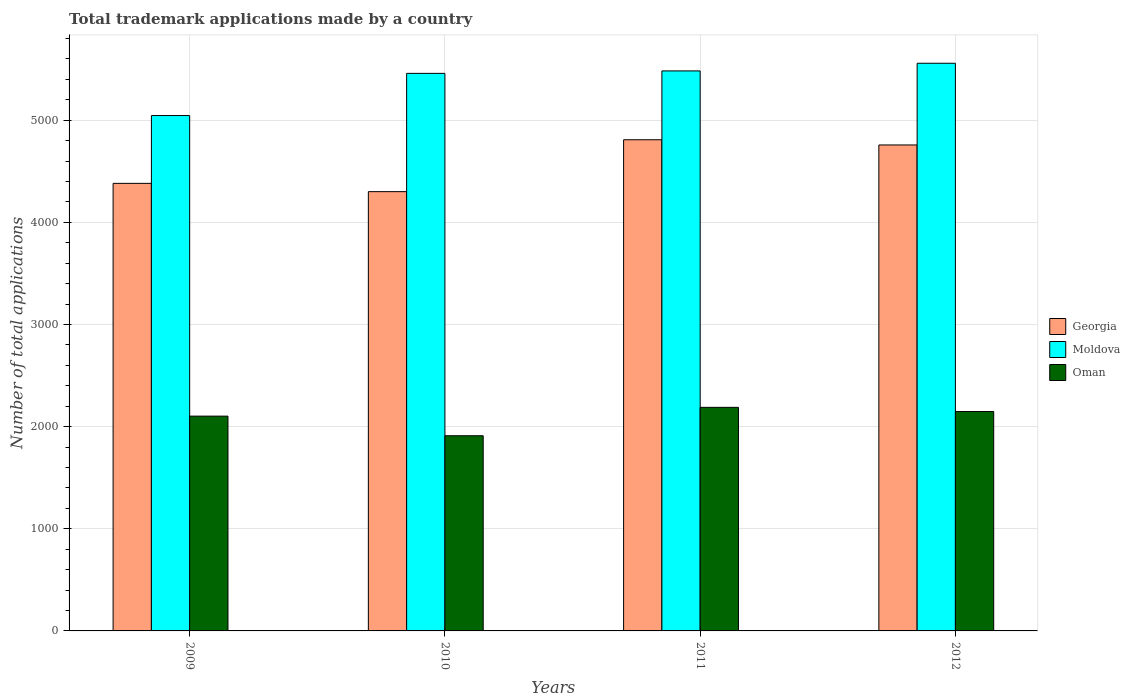How many different coloured bars are there?
Give a very brief answer. 3. Are the number of bars per tick equal to the number of legend labels?
Make the answer very short. Yes. How many bars are there on the 3rd tick from the right?
Offer a terse response. 3. What is the number of applications made by in Moldova in 2011?
Provide a short and direct response. 5483. Across all years, what is the maximum number of applications made by in Moldova?
Offer a very short reply. 5558. Across all years, what is the minimum number of applications made by in Moldova?
Your response must be concise. 5046. In which year was the number of applications made by in Moldova maximum?
Your response must be concise. 2012. In which year was the number of applications made by in Georgia minimum?
Offer a terse response. 2010. What is the total number of applications made by in Georgia in the graph?
Make the answer very short. 1.82e+04. What is the difference between the number of applications made by in Moldova in 2009 and that in 2011?
Keep it short and to the point. -437. What is the difference between the number of applications made by in Georgia in 2011 and the number of applications made by in Oman in 2009?
Offer a terse response. 2706. What is the average number of applications made by in Oman per year?
Provide a succinct answer. 2087.75. In the year 2012, what is the difference between the number of applications made by in Oman and number of applications made by in Moldova?
Keep it short and to the point. -3410. What is the ratio of the number of applications made by in Oman in 2010 to that in 2012?
Offer a very short reply. 0.89. Is the difference between the number of applications made by in Oman in 2009 and 2010 greater than the difference between the number of applications made by in Moldova in 2009 and 2010?
Keep it short and to the point. Yes. What is the difference between the highest and the second highest number of applications made by in Moldova?
Make the answer very short. 75. What is the difference between the highest and the lowest number of applications made by in Oman?
Offer a terse response. 278. In how many years, is the number of applications made by in Oman greater than the average number of applications made by in Oman taken over all years?
Give a very brief answer. 3. Is the sum of the number of applications made by in Moldova in 2009 and 2011 greater than the maximum number of applications made by in Georgia across all years?
Make the answer very short. Yes. What does the 1st bar from the left in 2012 represents?
Your response must be concise. Georgia. What does the 1st bar from the right in 2011 represents?
Provide a succinct answer. Oman. Is it the case that in every year, the sum of the number of applications made by in Moldova and number of applications made by in Oman is greater than the number of applications made by in Georgia?
Make the answer very short. Yes. Are all the bars in the graph horizontal?
Provide a succinct answer. No. Are the values on the major ticks of Y-axis written in scientific E-notation?
Your answer should be very brief. No. How are the legend labels stacked?
Your answer should be very brief. Vertical. What is the title of the graph?
Offer a very short reply. Total trademark applications made by a country. What is the label or title of the Y-axis?
Your answer should be compact. Number of total applications. What is the Number of total applications in Georgia in 2009?
Your response must be concise. 4382. What is the Number of total applications in Moldova in 2009?
Make the answer very short. 5046. What is the Number of total applications in Oman in 2009?
Offer a terse response. 2103. What is the Number of total applications of Georgia in 2010?
Your answer should be compact. 4301. What is the Number of total applications of Moldova in 2010?
Offer a very short reply. 5459. What is the Number of total applications of Oman in 2010?
Make the answer very short. 1911. What is the Number of total applications of Georgia in 2011?
Make the answer very short. 4809. What is the Number of total applications of Moldova in 2011?
Your answer should be very brief. 5483. What is the Number of total applications in Oman in 2011?
Your answer should be very brief. 2189. What is the Number of total applications in Georgia in 2012?
Offer a terse response. 4758. What is the Number of total applications of Moldova in 2012?
Keep it short and to the point. 5558. What is the Number of total applications in Oman in 2012?
Your response must be concise. 2148. Across all years, what is the maximum Number of total applications in Georgia?
Provide a short and direct response. 4809. Across all years, what is the maximum Number of total applications of Moldova?
Offer a very short reply. 5558. Across all years, what is the maximum Number of total applications of Oman?
Offer a terse response. 2189. Across all years, what is the minimum Number of total applications in Georgia?
Your response must be concise. 4301. Across all years, what is the minimum Number of total applications in Moldova?
Give a very brief answer. 5046. Across all years, what is the minimum Number of total applications of Oman?
Provide a succinct answer. 1911. What is the total Number of total applications in Georgia in the graph?
Provide a succinct answer. 1.82e+04. What is the total Number of total applications of Moldova in the graph?
Provide a short and direct response. 2.15e+04. What is the total Number of total applications in Oman in the graph?
Give a very brief answer. 8351. What is the difference between the Number of total applications in Georgia in 2009 and that in 2010?
Your answer should be compact. 81. What is the difference between the Number of total applications in Moldova in 2009 and that in 2010?
Offer a terse response. -413. What is the difference between the Number of total applications of Oman in 2009 and that in 2010?
Your response must be concise. 192. What is the difference between the Number of total applications of Georgia in 2009 and that in 2011?
Make the answer very short. -427. What is the difference between the Number of total applications in Moldova in 2009 and that in 2011?
Keep it short and to the point. -437. What is the difference between the Number of total applications in Oman in 2009 and that in 2011?
Your response must be concise. -86. What is the difference between the Number of total applications in Georgia in 2009 and that in 2012?
Your answer should be very brief. -376. What is the difference between the Number of total applications in Moldova in 2009 and that in 2012?
Keep it short and to the point. -512. What is the difference between the Number of total applications of Oman in 2009 and that in 2012?
Your answer should be compact. -45. What is the difference between the Number of total applications in Georgia in 2010 and that in 2011?
Your response must be concise. -508. What is the difference between the Number of total applications of Oman in 2010 and that in 2011?
Your answer should be compact. -278. What is the difference between the Number of total applications in Georgia in 2010 and that in 2012?
Give a very brief answer. -457. What is the difference between the Number of total applications of Moldova in 2010 and that in 2012?
Your response must be concise. -99. What is the difference between the Number of total applications of Oman in 2010 and that in 2012?
Offer a terse response. -237. What is the difference between the Number of total applications of Georgia in 2011 and that in 2012?
Your response must be concise. 51. What is the difference between the Number of total applications of Moldova in 2011 and that in 2012?
Keep it short and to the point. -75. What is the difference between the Number of total applications in Georgia in 2009 and the Number of total applications in Moldova in 2010?
Offer a terse response. -1077. What is the difference between the Number of total applications of Georgia in 2009 and the Number of total applications of Oman in 2010?
Keep it short and to the point. 2471. What is the difference between the Number of total applications of Moldova in 2009 and the Number of total applications of Oman in 2010?
Ensure brevity in your answer.  3135. What is the difference between the Number of total applications of Georgia in 2009 and the Number of total applications of Moldova in 2011?
Offer a very short reply. -1101. What is the difference between the Number of total applications of Georgia in 2009 and the Number of total applications of Oman in 2011?
Provide a succinct answer. 2193. What is the difference between the Number of total applications of Moldova in 2009 and the Number of total applications of Oman in 2011?
Keep it short and to the point. 2857. What is the difference between the Number of total applications in Georgia in 2009 and the Number of total applications in Moldova in 2012?
Keep it short and to the point. -1176. What is the difference between the Number of total applications of Georgia in 2009 and the Number of total applications of Oman in 2012?
Keep it short and to the point. 2234. What is the difference between the Number of total applications in Moldova in 2009 and the Number of total applications in Oman in 2012?
Your response must be concise. 2898. What is the difference between the Number of total applications of Georgia in 2010 and the Number of total applications of Moldova in 2011?
Your answer should be compact. -1182. What is the difference between the Number of total applications in Georgia in 2010 and the Number of total applications in Oman in 2011?
Offer a very short reply. 2112. What is the difference between the Number of total applications in Moldova in 2010 and the Number of total applications in Oman in 2011?
Ensure brevity in your answer.  3270. What is the difference between the Number of total applications in Georgia in 2010 and the Number of total applications in Moldova in 2012?
Your answer should be compact. -1257. What is the difference between the Number of total applications of Georgia in 2010 and the Number of total applications of Oman in 2012?
Offer a terse response. 2153. What is the difference between the Number of total applications of Moldova in 2010 and the Number of total applications of Oman in 2012?
Ensure brevity in your answer.  3311. What is the difference between the Number of total applications of Georgia in 2011 and the Number of total applications of Moldova in 2012?
Offer a very short reply. -749. What is the difference between the Number of total applications in Georgia in 2011 and the Number of total applications in Oman in 2012?
Your answer should be very brief. 2661. What is the difference between the Number of total applications of Moldova in 2011 and the Number of total applications of Oman in 2012?
Your response must be concise. 3335. What is the average Number of total applications of Georgia per year?
Your answer should be compact. 4562.5. What is the average Number of total applications of Moldova per year?
Offer a terse response. 5386.5. What is the average Number of total applications in Oman per year?
Your answer should be very brief. 2087.75. In the year 2009, what is the difference between the Number of total applications of Georgia and Number of total applications of Moldova?
Your answer should be compact. -664. In the year 2009, what is the difference between the Number of total applications in Georgia and Number of total applications in Oman?
Give a very brief answer. 2279. In the year 2009, what is the difference between the Number of total applications in Moldova and Number of total applications in Oman?
Provide a succinct answer. 2943. In the year 2010, what is the difference between the Number of total applications of Georgia and Number of total applications of Moldova?
Make the answer very short. -1158. In the year 2010, what is the difference between the Number of total applications of Georgia and Number of total applications of Oman?
Offer a terse response. 2390. In the year 2010, what is the difference between the Number of total applications in Moldova and Number of total applications in Oman?
Provide a succinct answer. 3548. In the year 2011, what is the difference between the Number of total applications of Georgia and Number of total applications of Moldova?
Provide a succinct answer. -674. In the year 2011, what is the difference between the Number of total applications of Georgia and Number of total applications of Oman?
Offer a very short reply. 2620. In the year 2011, what is the difference between the Number of total applications of Moldova and Number of total applications of Oman?
Give a very brief answer. 3294. In the year 2012, what is the difference between the Number of total applications of Georgia and Number of total applications of Moldova?
Your response must be concise. -800. In the year 2012, what is the difference between the Number of total applications in Georgia and Number of total applications in Oman?
Make the answer very short. 2610. In the year 2012, what is the difference between the Number of total applications in Moldova and Number of total applications in Oman?
Your answer should be very brief. 3410. What is the ratio of the Number of total applications in Georgia in 2009 to that in 2010?
Make the answer very short. 1.02. What is the ratio of the Number of total applications in Moldova in 2009 to that in 2010?
Make the answer very short. 0.92. What is the ratio of the Number of total applications in Oman in 2009 to that in 2010?
Provide a short and direct response. 1.1. What is the ratio of the Number of total applications in Georgia in 2009 to that in 2011?
Give a very brief answer. 0.91. What is the ratio of the Number of total applications of Moldova in 2009 to that in 2011?
Your response must be concise. 0.92. What is the ratio of the Number of total applications in Oman in 2009 to that in 2011?
Your response must be concise. 0.96. What is the ratio of the Number of total applications in Georgia in 2009 to that in 2012?
Provide a succinct answer. 0.92. What is the ratio of the Number of total applications in Moldova in 2009 to that in 2012?
Your answer should be very brief. 0.91. What is the ratio of the Number of total applications in Oman in 2009 to that in 2012?
Give a very brief answer. 0.98. What is the ratio of the Number of total applications of Georgia in 2010 to that in 2011?
Your response must be concise. 0.89. What is the ratio of the Number of total applications of Oman in 2010 to that in 2011?
Offer a very short reply. 0.87. What is the ratio of the Number of total applications of Georgia in 2010 to that in 2012?
Your answer should be very brief. 0.9. What is the ratio of the Number of total applications in Moldova in 2010 to that in 2012?
Offer a very short reply. 0.98. What is the ratio of the Number of total applications in Oman in 2010 to that in 2012?
Keep it short and to the point. 0.89. What is the ratio of the Number of total applications in Georgia in 2011 to that in 2012?
Offer a very short reply. 1.01. What is the ratio of the Number of total applications in Moldova in 2011 to that in 2012?
Your response must be concise. 0.99. What is the ratio of the Number of total applications in Oman in 2011 to that in 2012?
Your answer should be compact. 1.02. What is the difference between the highest and the second highest Number of total applications of Georgia?
Your response must be concise. 51. What is the difference between the highest and the second highest Number of total applications of Moldova?
Keep it short and to the point. 75. What is the difference between the highest and the lowest Number of total applications in Georgia?
Provide a short and direct response. 508. What is the difference between the highest and the lowest Number of total applications in Moldova?
Offer a terse response. 512. What is the difference between the highest and the lowest Number of total applications of Oman?
Your response must be concise. 278. 